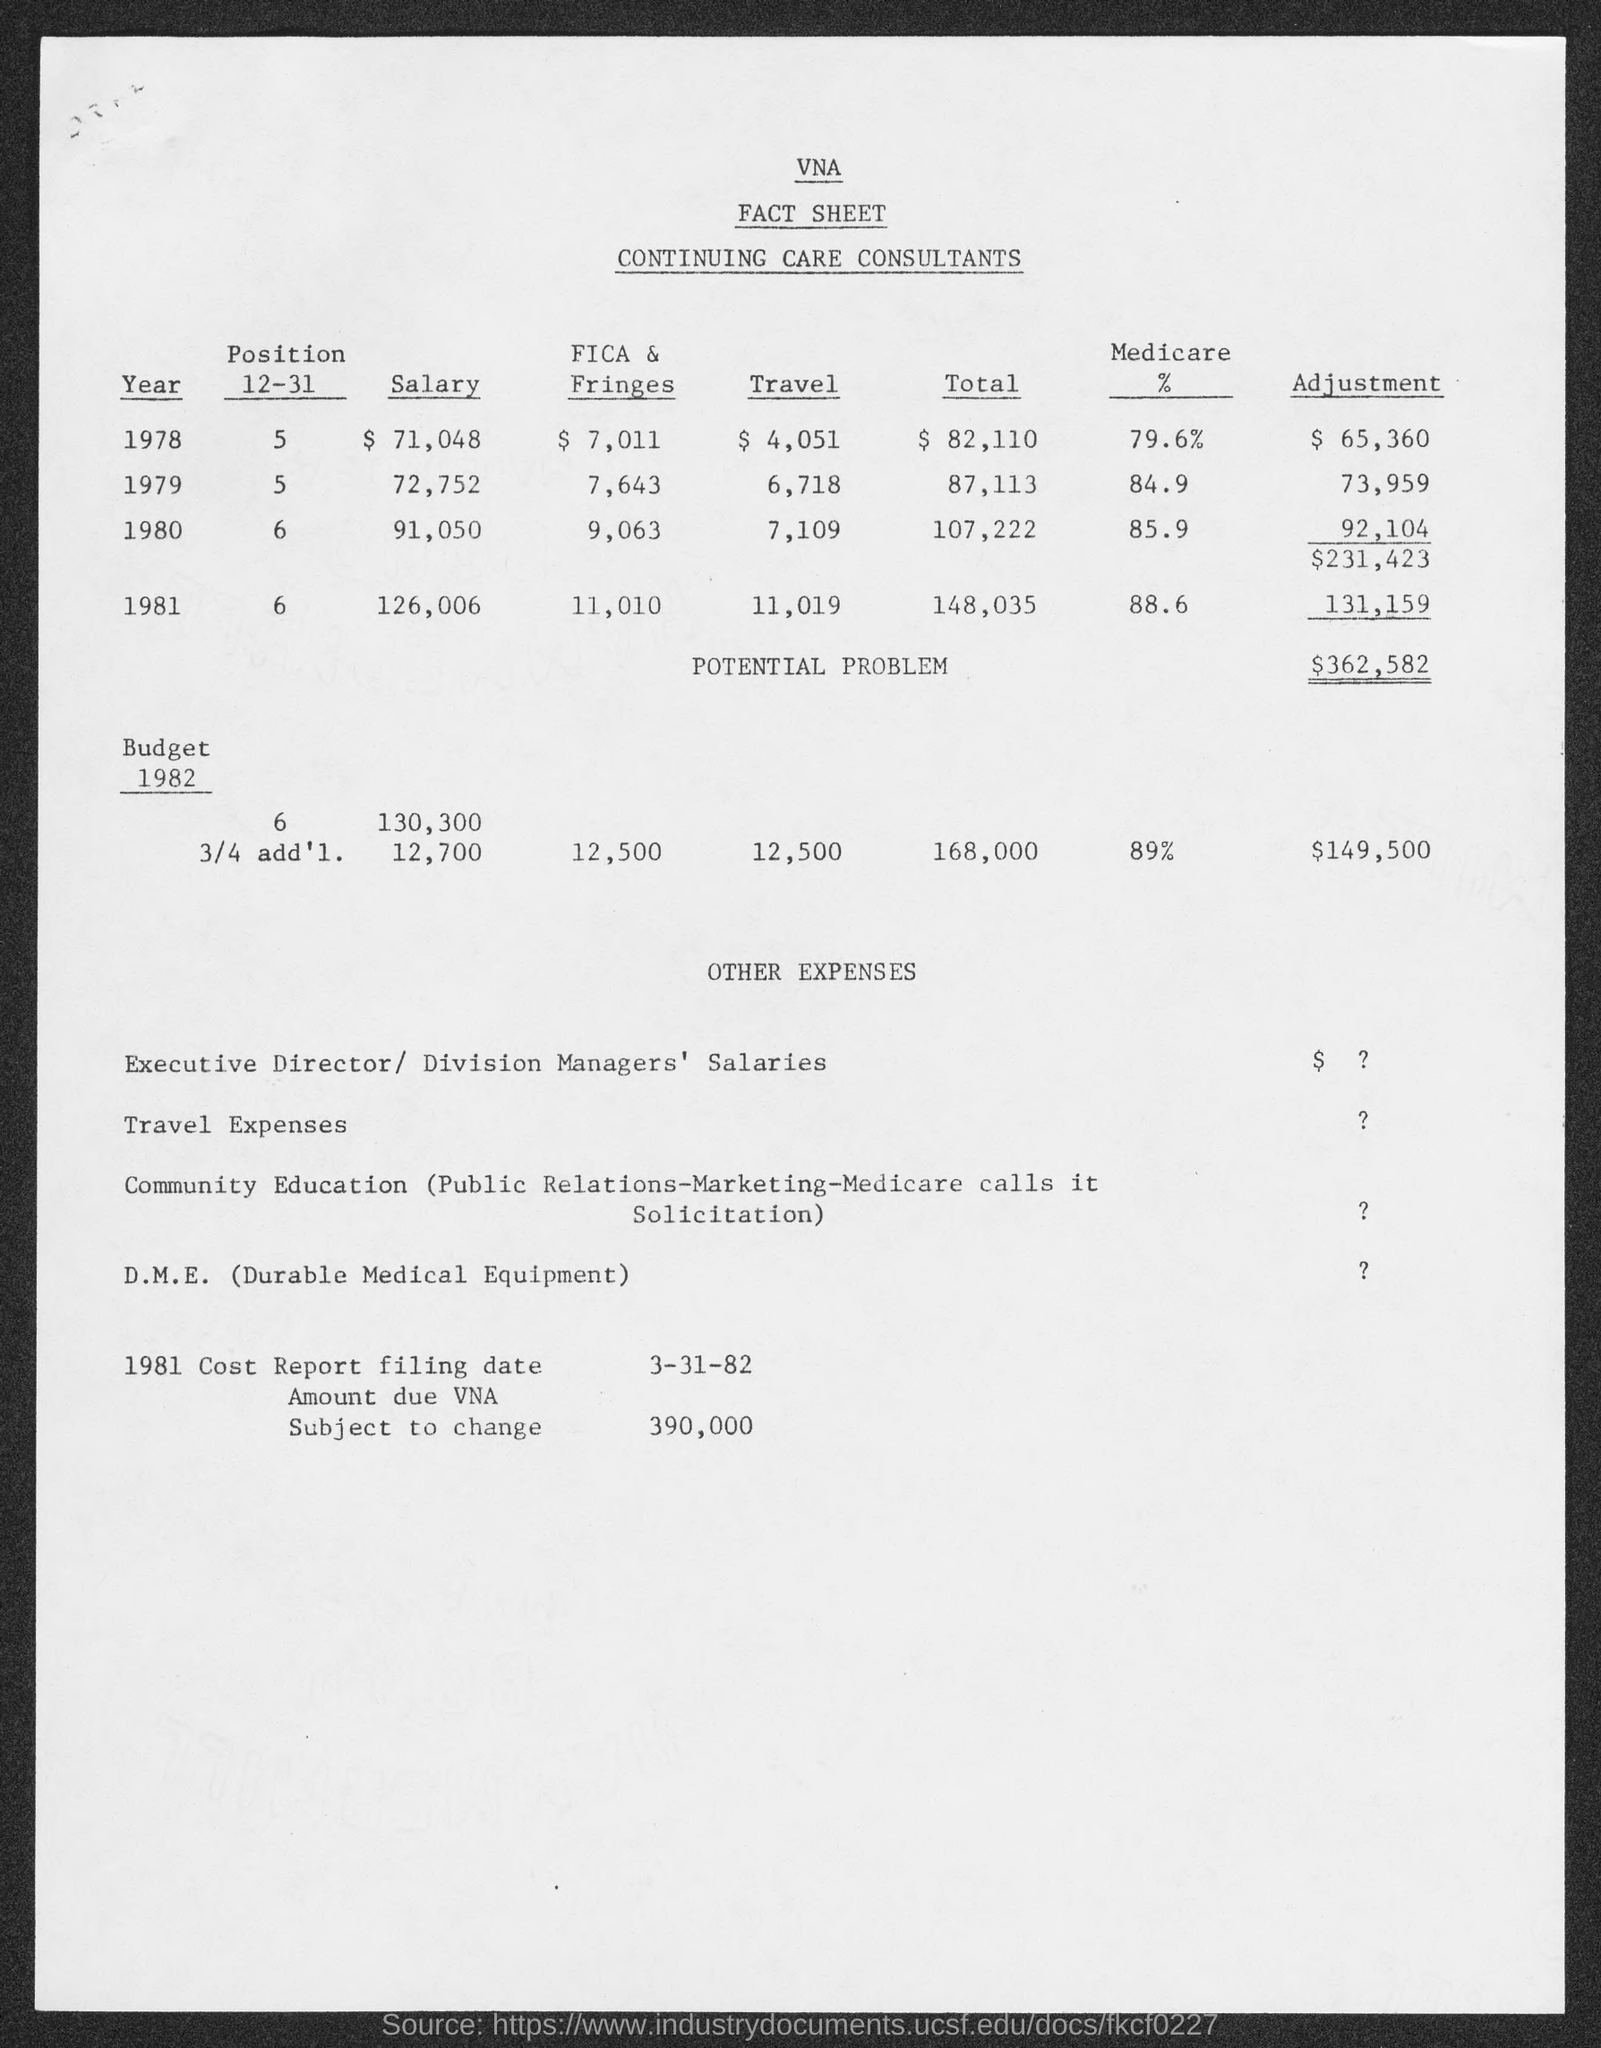Draw attention to some important aspects in this diagram. The total "POTENTIAL PROBLEM" amount is $362,582. I, D.M.E, am a type of durable medical equipment that is used to assist individuals with various medical needs. The salary amount for 1978 was $71,048. The heading of the first column of the first table is labeled as 'Year'. The amount due for the VNA subject to change is 390,000. 